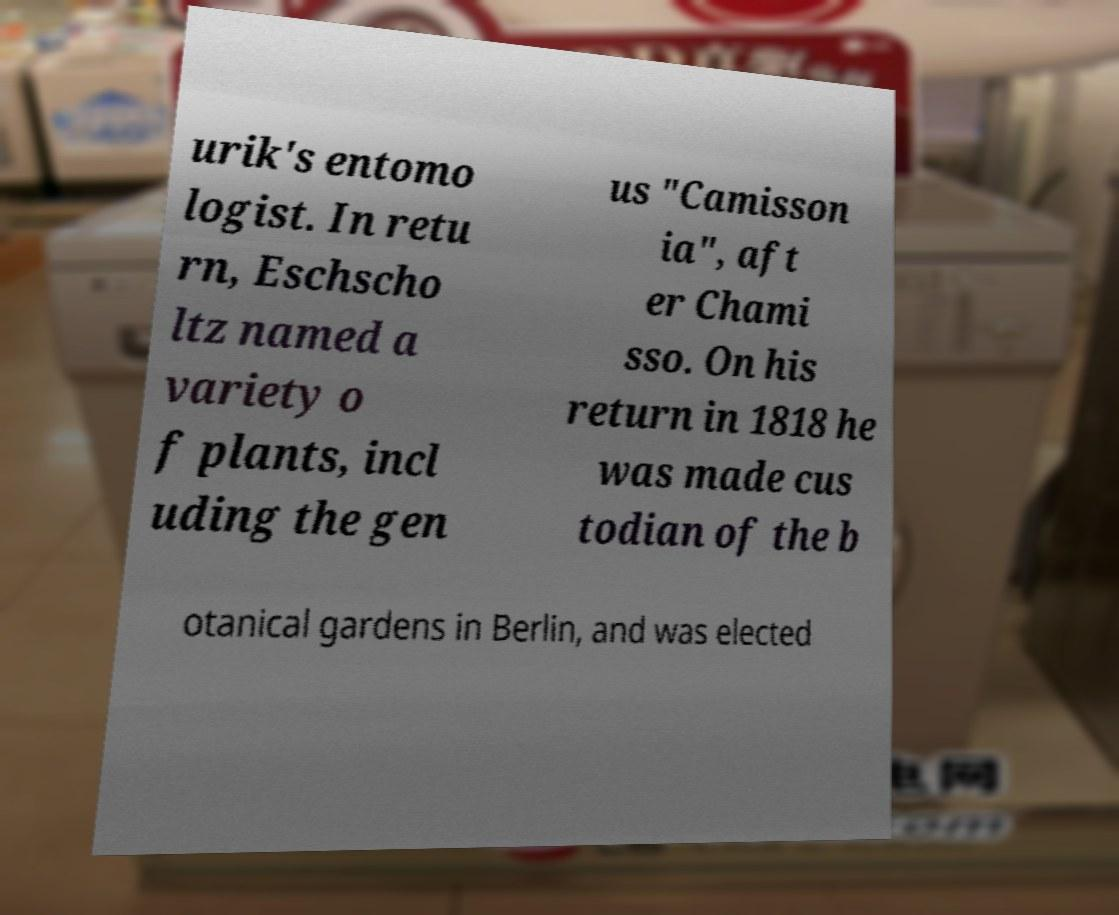Could you extract and type out the text from this image? urik's entomo logist. In retu rn, Eschscho ltz named a variety o f plants, incl uding the gen us "Camisson ia", aft er Chami sso. On his return in 1818 he was made cus todian of the b otanical gardens in Berlin, and was elected 